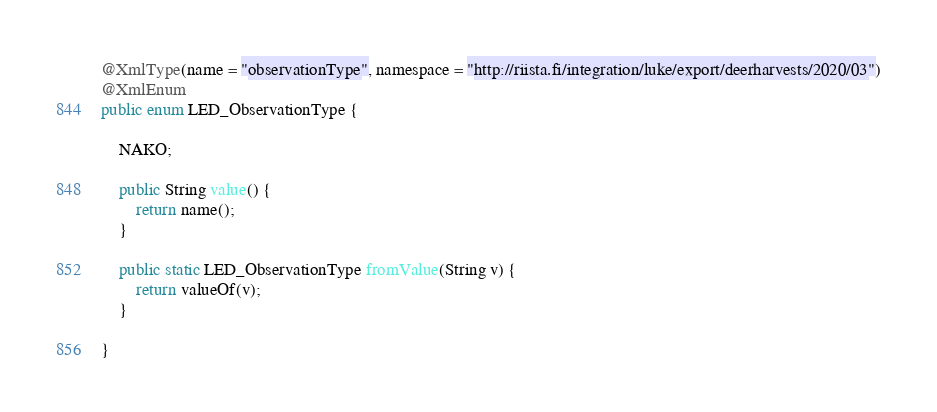<code> <loc_0><loc_0><loc_500><loc_500><_Java_>@XmlType(name = "observationType", namespace = "http://riista.fi/integration/luke/export/deerharvests/2020/03")
@XmlEnum
public enum LED_ObservationType {

    NAKO;

    public String value() {
        return name();
    }

    public static LED_ObservationType fromValue(String v) {
        return valueOf(v);
    }

}
</code> 